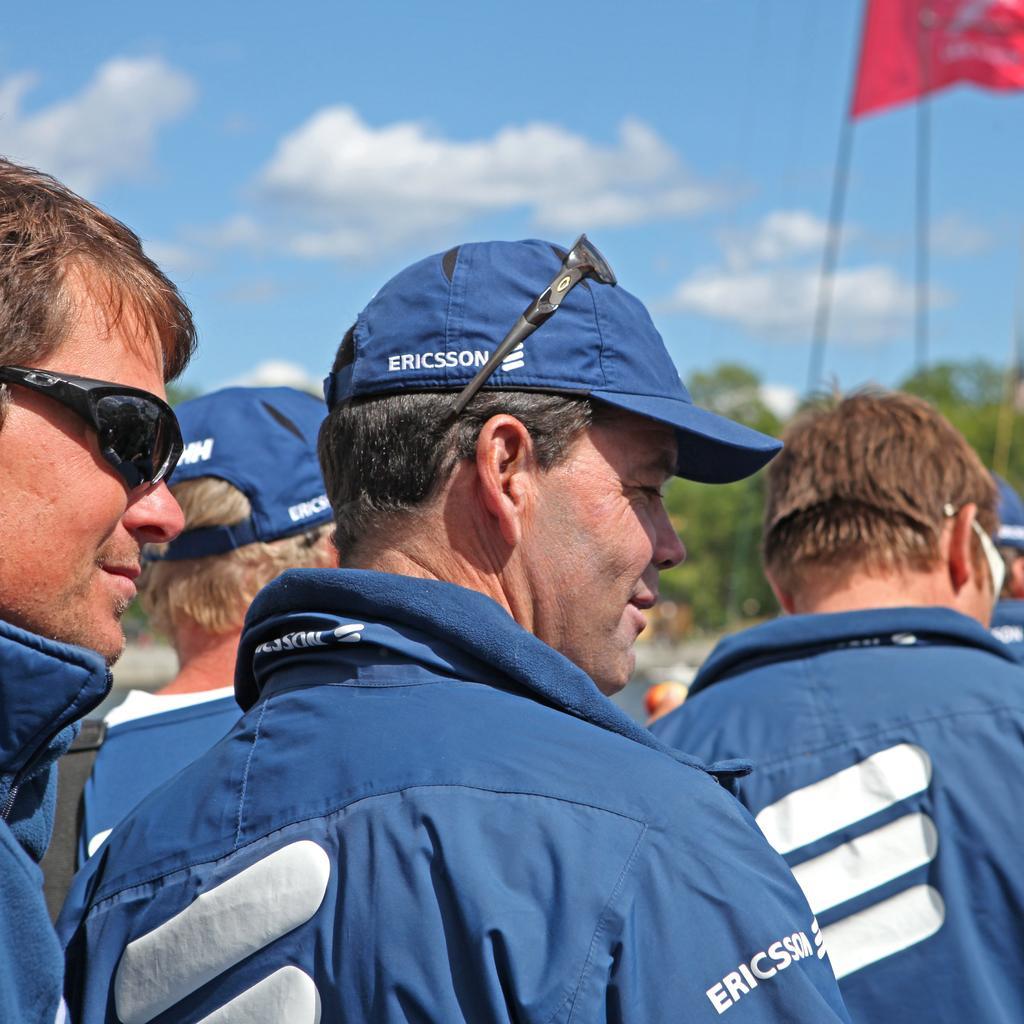Describe this image in one or two sentences. In this image there are people. On the right there is a flag. In the background there are trees and sky. 